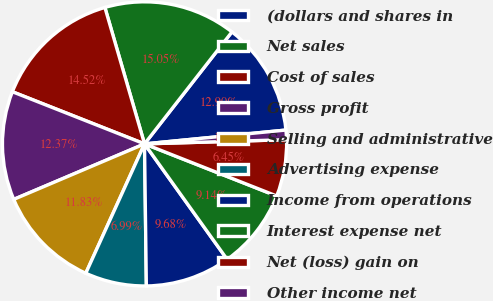Convert chart to OTSL. <chart><loc_0><loc_0><loc_500><loc_500><pie_chart><fcel>(dollars and shares in<fcel>Net sales<fcel>Cost of sales<fcel>Gross profit<fcel>Selling and administrative<fcel>Advertising expense<fcel>Income from operations<fcel>Interest expense net<fcel>Net (loss) gain on<fcel>Other income net<nl><fcel>12.9%<fcel>15.05%<fcel>14.52%<fcel>12.37%<fcel>11.83%<fcel>6.99%<fcel>9.68%<fcel>9.14%<fcel>6.45%<fcel>1.08%<nl></chart> 